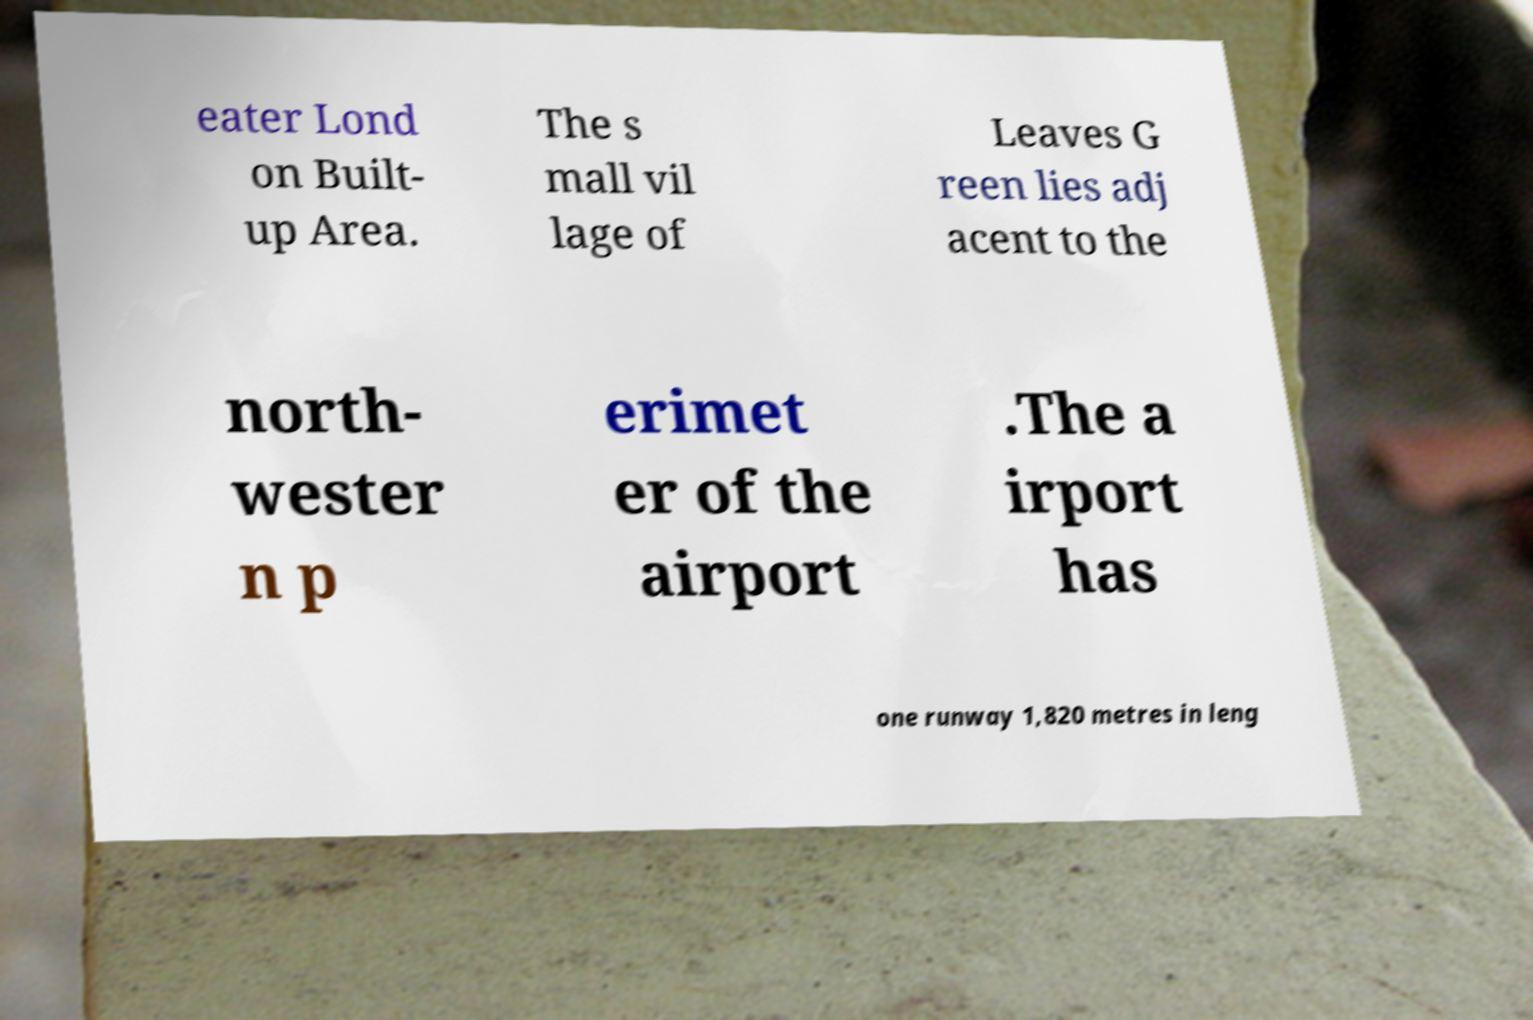For documentation purposes, I need the text within this image transcribed. Could you provide that? eater Lond on Built- up Area. The s mall vil lage of Leaves G reen lies adj acent to the north- wester n p erimet er of the airport .The a irport has one runway 1,820 metres in leng 